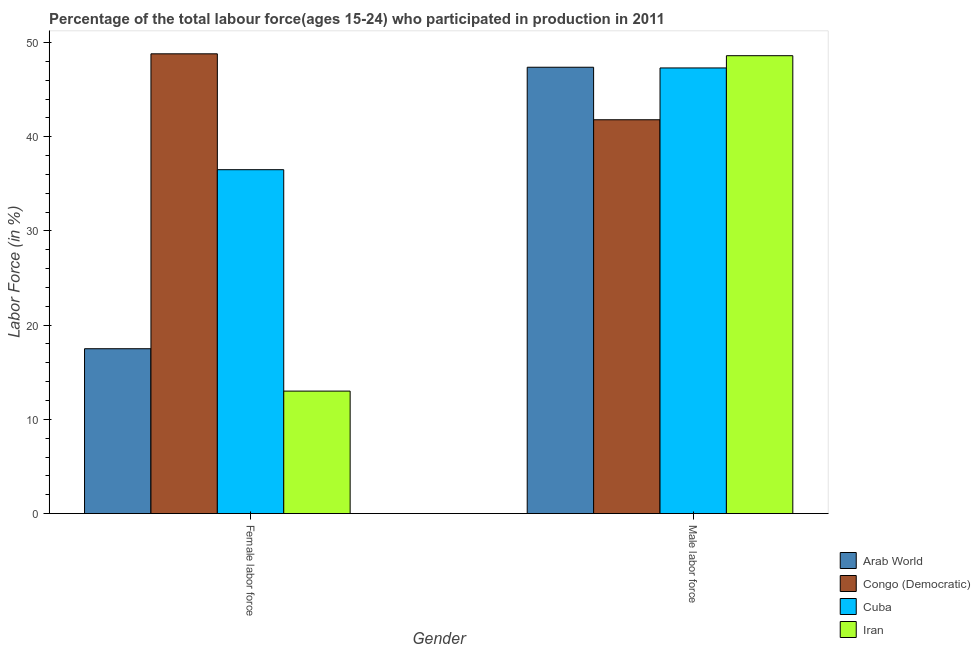How many groups of bars are there?
Make the answer very short. 2. Are the number of bars per tick equal to the number of legend labels?
Provide a succinct answer. Yes. Are the number of bars on each tick of the X-axis equal?
Your response must be concise. Yes. How many bars are there on the 1st tick from the left?
Your response must be concise. 4. What is the label of the 2nd group of bars from the left?
Provide a short and direct response. Male labor force. What is the percentage of male labour force in Cuba?
Keep it short and to the point. 47.3. Across all countries, what is the maximum percentage of female labor force?
Provide a succinct answer. 48.8. Across all countries, what is the minimum percentage of male labour force?
Your answer should be compact. 41.8. In which country was the percentage of male labour force maximum?
Provide a short and direct response. Iran. In which country was the percentage of female labor force minimum?
Provide a short and direct response. Iran. What is the total percentage of male labour force in the graph?
Ensure brevity in your answer.  185.07. What is the difference between the percentage of male labour force in Congo (Democratic) and that in Iran?
Make the answer very short. -6.8. What is the difference between the percentage of female labor force in Cuba and the percentage of male labour force in Arab World?
Provide a short and direct response. -10.87. What is the average percentage of female labor force per country?
Offer a terse response. 28.95. What is the difference between the percentage of female labor force and percentage of male labour force in Arab World?
Your answer should be very brief. -29.88. What is the ratio of the percentage of female labor force in Iran to that in Arab World?
Keep it short and to the point. 0.74. Is the percentage of female labor force in Cuba less than that in Arab World?
Offer a terse response. No. What does the 2nd bar from the left in Male labor force represents?
Ensure brevity in your answer.  Congo (Democratic). What does the 2nd bar from the right in Female labor force represents?
Provide a succinct answer. Cuba. How many bars are there?
Make the answer very short. 8. What is the difference between two consecutive major ticks on the Y-axis?
Provide a succinct answer. 10. Does the graph contain any zero values?
Offer a very short reply. No. Does the graph contain grids?
Offer a very short reply. No. Where does the legend appear in the graph?
Provide a succinct answer. Bottom right. How many legend labels are there?
Provide a short and direct response. 4. What is the title of the graph?
Provide a short and direct response. Percentage of the total labour force(ages 15-24) who participated in production in 2011. Does "Kenya" appear as one of the legend labels in the graph?
Give a very brief answer. No. What is the label or title of the X-axis?
Make the answer very short. Gender. What is the Labor Force (in %) in Arab World in Female labor force?
Offer a very short reply. 17.5. What is the Labor Force (in %) of Congo (Democratic) in Female labor force?
Provide a succinct answer. 48.8. What is the Labor Force (in %) of Cuba in Female labor force?
Provide a succinct answer. 36.5. What is the Labor Force (in %) of Arab World in Male labor force?
Offer a very short reply. 47.37. What is the Labor Force (in %) of Congo (Democratic) in Male labor force?
Provide a short and direct response. 41.8. What is the Labor Force (in %) of Cuba in Male labor force?
Keep it short and to the point. 47.3. What is the Labor Force (in %) of Iran in Male labor force?
Your answer should be compact. 48.6. Across all Gender, what is the maximum Labor Force (in %) of Arab World?
Offer a terse response. 47.37. Across all Gender, what is the maximum Labor Force (in %) in Congo (Democratic)?
Provide a short and direct response. 48.8. Across all Gender, what is the maximum Labor Force (in %) of Cuba?
Make the answer very short. 47.3. Across all Gender, what is the maximum Labor Force (in %) of Iran?
Provide a short and direct response. 48.6. Across all Gender, what is the minimum Labor Force (in %) in Arab World?
Offer a very short reply. 17.5. Across all Gender, what is the minimum Labor Force (in %) in Congo (Democratic)?
Provide a succinct answer. 41.8. Across all Gender, what is the minimum Labor Force (in %) in Cuba?
Make the answer very short. 36.5. What is the total Labor Force (in %) of Arab World in the graph?
Your answer should be compact. 64.87. What is the total Labor Force (in %) of Congo (Democratic) in the graph?
Your answer should be very brief. 90.6. What is the total Labor Force (in %) in Cuba in the graph?
Keep it short and to the point. 83.8. What is the total Labor Force (in %) in Iran in the graph?
Your response must be concise. 61.6. What is the difference between the Labor Force (in %) of Arab World in Female labor force and that in Male labor force?
Make the answer very short. -29.88. What is the difference between the Labor Force (in %) of Congo (Democratic) in Female labor force and that in Male labor force?
Your answer should be compact. 7. What is the difference between the Labor Force (in %) of Iran in Female labor force and that in Male labor force?
Your response must be concise. -35.6. What is the difference between the Labor Force (in %) of Arab World in Female labor force and the Labor Force (in %) of Congo (Democratic) in Male labor force?
Offer a very short reply. -24.3. What is the difference between the Labor Force (in %) of Arab World in Female labor force and the Labor Force (in %) of Cuba in Male labor force?
Provide a succinct answer. -29.8. What is the difference between the Labor Force (in %) in Arab World in Female labor force and the Labor Force (in %) in Iran in Male labor force?
Ensure brevity in your answer.  -31.1. What is the difference between the Labor Force (in %) in Congo (Democratic) in Female labor force and the Labor Force (in %) in Cuba in Male labor force?
Offer a very short reply. 1.5. What is the difference between the Labor Force (in %) in Congo (Democratic) in Female labor force and the Labor Force (in %) in Iran in Male labor force?
Give a very brief answer. 0.2. What is the difference between the Labor Force (in %) in Cuba in Female labor force and the Labor Force (in %) in Iran in Male labor force?
Provide a succinct answer. -12.1. What is the average Labor Force (in %) of Arab World per Gender?
Your answer should be very brief. 32.44. What is the average Labor Force (in %) of Congo (Democratic) per Gender?
Your answer should be very brief. 45.3. What is the average Labor Force (in %) in Cuba per Gender?
Make the answer very short. 41.9. What is the average Labor Force (in %) of Iran per Gender?
Keep it short and to the point. 30.8. What is the difference between the Labor Force (in %) in Arab World and Labor Force (in %) in Congo (Democratic) in Female labor force?
Keep it short and to the point. -31.3. What is the difference between the Labor Force (in %) of Arab World and Labor Force (in %) of Cuba in Female labor force?
Keep it short and to the point. -19. What is the difference between the Labor Force (in %) in Arab World and Labor Force (in %) in Iran in Female labor force?
Your response must be concise. 4.5. What is the difference between the Labor Force (in %) of Congo (Democratic) and Labor Force (in %) of Iran in Female labor force?
Provide a short and direct response. 35.8. What is the difference between the Labor Force (in %) in Arab World and Labor Force (in %) in Congo (Democratic) in Male labor force?
Your answer should be compact. 5.57. What is the difference between the Labor Force (in %) of Arab World and Labor Force (in %) of Cuba in Male labor force?
Keep it short and to the point. 0.07. What is the difference between the Labor Force (in %) of Arab World and Labor Force (in %) of Iran in Male labor force?
Make the answer very short. -1.23. What is the ratio of the Labor Force (in %) in Arab World in Female labor force to that in Male labor force?
Offer a terse response. 0.37. What is the ratio of the Labor Force (in %) in Congo (Democratic) in Female labor force to that in Male labor force?
Your response must be concise. 1.17. What is the ratio of the Labor Force (in %) in Cuba in Female labor force to that in Male labor force?
Provide a short and direct response. 0.77. What is the ratio of the Labor Force (in %) of Iran in Female labor force to that in Male labor force?
Provide a short and direct response. 0.27. What is the difference between the highest and the second highest Labor Force (in %) in Arab World?
Offer a terse response. 29.88. What is the difference between the highest and the second highest Labor Force (in %) in Congo (Democratic)?
Provide a succinct answer. 7. What is the difference between the highest and the second highest Labor Force (in %) in Cuba?
Provide a succinct answer. 10.8. What is the difference between the highest and the second highest Labor Force (in %) in Iran?
Your response must be concise. 35.6. What is the difference between the highest and the lowest Labor Force (in %) of Arab World?
Offer a very short reply. 29.88. What is the difference between the highest and the lowest Labor Force (in %) of Congo (Democratic)?
Offer a very short reply. 7. What is the difference between the highest and the lowest Labor Force (in %) of Iran?
Provide a succinct answer. 35.6. 